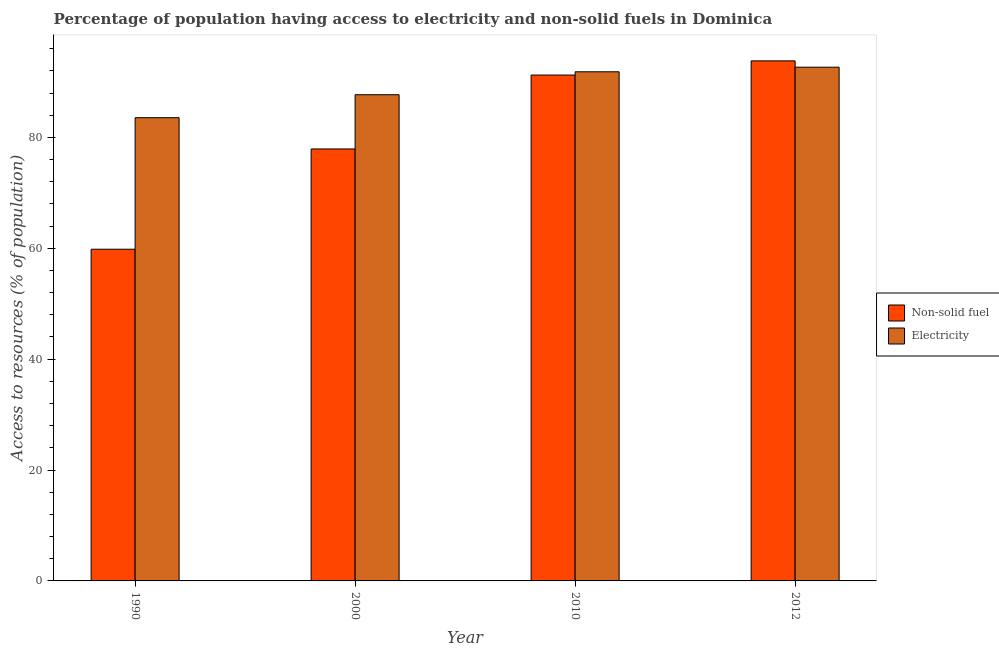Are the number of bars per tick equal to the number of legend labels?
Your answer should be compact. Yes. Are the number of bars on each tick of the X-axis equal?
Offer a very short reply. Yes. How many bars are there on the 2nd tick from the left?
Make the answer very short. 2. How many bars are there on the 2nd tick from the right?
Your answer should be compact. 2. What is the percentage of population having access to non-solid fuel in 1990?
Keep it short and to the point. 59.83. Across all years, what is the maximum percentage of population having access to electricity?
Provide a succinct answer. 92.67. Across all years, what is the minimum percentage of population having access to non-solid fuel?
Offer a terse response. 59.83. What is the total percentage of population having access to non-solid fuel in the graph?
Provide a short and direct response. 322.81. What is the difference between the percentage of population having access to non-solid fuel in 2000 and that in 2010?
Make the answer very short. -13.33. What is the difference between the percentage of population having access to non-solid fuel in 1990 and the percentage of population having access to electricity in 2012?
Provide a short and direct response. -33.97. What is the average percentage of population having access to non-solid fuel per year?
Make the answer very short. 80.7. In how many years, is the percentage of population having access to electricity greater than 48 %?
Make the answer very short. 4. What is the ratio of the percentage of population having access to non-solid fuel in 1990 to that in 2000?
Offer a very short reply. 0.77. What is the difference between the highest and the second highest percentage of population having access to non-solid fuel?
Provide a succinct answer. 2.56. What is the difference between the highest and the lowest percentage of population having access to electricity?
Your answer should be very brief. 9.11. What does the 2nd bar from the left in 2012 represents?
Offer a very short reply. Electricity. What does the 2nd bar from the right in 1990 represents?
Provide a succinct answer. Non-solid fuel. Are all the bars in the graph horizontal?
Ensure brevity in your answer.  No. How many years are there in the graph?
Make the answer very short. 4. Does the graph contain any zero values?
Offer a very short reply. No. Does the graph contain grids?
Give a very brief answer. No. Where does the legend appear in the graph?
Your response must be concise. Center right. How many legend labels are there?
Give a very brief answer. 2. How are the legend labels stacked?
Ensure brevity in your answer.  Vertical. What is the title of the graph?
Provide a succinct answer. Percentage of population having access to electricity and non-solid fuels in Dominica. What is the label or title of the X-axis?
Your response must be concise. Year. What is the label or title of the Y-axis?
Provide a succinct answer. Access to resources (% of population). What is the Access to resources (% of population) of Non-solid fuel in 1990?
Provide a short and direct response. 59.83. What is the Access to resources (% of population) in Electricity in 1990?
Your answer should be very brief. 83.56. What is the Access to resources (% of population) in Non-solid fuel in 2000?
Give a very brief answer. 77.92. What is the Access to resources (% of population) of Electricity in 2000?
Offer a terse response. 87.7. What is the Access to resources (% of population) of Non-solid fuel in 2010?
Provide a short and direct response. 91.25. What is the Access to resources (% of population) in Electricity in 2010?
Keep it short and to the point. 91.84. What is the Access to resources (% of population) of Non-solid fuel in 2012?
Give a very brief answer. 93.81. What is the Access to resources (% of population) of Electricity in 2012?
Keep it short and to the point. 92.67. Across all years, what is the maximum Access to resources (% of population) of Non-solid fuel?
Ensure brevity in your answer.  93.81. Across all years, what is the maximum Access to resources (% of population) in Electricity?
Offer a very short reply. 92.67. Across all years, what is the minimum Access to resources (% of population) of Non-solid fuel?
Give a very brief answer. 59.83. Across all years, what is the minimum Access to resources (% of population) in Electricity?
Make the answer very short. 83.56. What is the total Access to resources (% of population) of Non-solid fuel in the graph?
Your answer should be compact. 322.81. What is the total Access to resources (% of population) of Electricity in the graph?
Offer a terse response. 355.77. What is the difference between the Access to resources (% of population) of Non-solid fuel in 1990 and that in 2000?
Make the answer very short. -18.09. What is the difference between the Access to resources (% of population) in Electricity in 1990 and that in 2000?
Ensure brevity in your answer.  -4.14. What is the difference between the Access to resources (% of population) in Non-solid fuel in 1990 and that in 2010?
Your response must be concise. -31.42. What is the difference between the Access to resources (% of population) in Electricity in 1990 and that in 2010?
Offer a very short reply. -8.28. What is the difference between the Access to resources (% of population) of Non-solid fuel in 1990 and that in 2012?
Your response must be concise. -33.97. What is the difference between the Access to resources (% of population) in Electricity in 1990 and that in 2012?
Your answer should be compact. -9.11. What is the difference between the Access to resources (% of population) in Non-solid fuel in 2000 and that in 2010?
Provide a short and direct response. -13.33. What is the difference between the Access to resources (% of population) of Electricity in 2000 and that in 2010?
Your answer should be compact. -4.14. What is the difference between the Access to resources (% of population) in Non-solid fuel in 2000 and that in 2012?
Give a very brief answer. -15.89. What is the difference between the Access to resources (% of population) in Electricity in 2000 and that in 2012?
Your answer should be very brief. -4.97. What is the difference between the Access to resources (% of population) in Non-solid fuel in 2010 and that in 2012?
Give a very brief answer. -2.56. What is the difference between the Access to resources (% of population) in Electricity in 2010 and that in 2012?
Provide a short and direct response. -0.83. What is the difference between the Access to resources (% of population) of Non-solid fuel in 1990 and the Access to resources (% of population) of Electricity in 2000?
Your answer should be compact. -27.87. What is the difference between the Access to resources (% of population) of Non-solid fuel in 1990 and the Access to resources (% of population) of Electricity in 2010?
Make the answer very short. -32.01. What is the difference between the Access to resources (% of population) of Non-solid fuel in 1990 and the Access to resources (% of population) of Electricity in 2012?
Offer a terse response. -32.83. What is the difference between the Access to resources (% of population) of Non-solid fuel in 2000 and the Access to resources (% of population) of Electricity in 2010?
Ensure brevity in your answer.  -13.92. What is the difference between the Access to resources (% of population) of Non-solid fuel in 2000 and the Access to resources (% of population) of Electricity in 2012?
Offer a very short reply. -14.75. What is the difference between the Access to resources (% of population) of Non-solid fuel in 2010 and the Access to resources (% of population) of Electricity in 2012?
Provide a succinct answer. -1.42. What is the average Access to resources (% of population) in Non-solid fuel per year?
Give a very brief answer. 80.7. What is the average Access to resources (% of population) in Electricity per year?
Offer a terse response. 88.94. In the year 1990, what is the difference between the Access to resources (% of population) in Non-solid fuel and Access to resources (% of population) in Electricity?
Make the answer very short. -23.73. In the year 2000, what is the difference between the Access to resources (% of population) in Non-solid fuel and Access to resources (% of population) in Electricity?
Your answer should be very brief. -9.78. In the year 2010, what is the difference between the Access to resources (% of population) in Non-solid fuel and Access to resources (% of population) in Electricity?
Offer a terse response. -0.59. In the year 2012, what is the difference between the Access to resources (% of population) in Non-solid fuel and Access to resources (% of population) in Electricity?
Your answer should be compact. 1.14. What is the ratio of the Access to resources (% of population) of Non-solid fuel in 1990 to that in 2000?
Your answer should be very brief. 0.77. What is the ratio of the Access to resources (% of population) in Electricity in 1990 to that in 2000?
Make the answer very short. 0.95. What is the ratio of the Access to resources (% of population) of Non-solid fuel in 1990 to that in 2010?
Provide a succinct answer. 0.66. What is the ratio of the Access to resources (% of population) of Electricity in 1990 to that in 2010?
Your response must be concise. 0.91. What is the ratio of the Access to resources (% of population) of Non-solid fuel in 1990 to that in 2012?
Keep it short and to the point. 0.64. What is the ratio of the Access to resources (% of population) in Electricity in 1990 to that in 2012?
Make the answer very short. 0.9. What is the ratio of the Access to resources (% of population) of Non-solid fuel in 2000 to that in 2010?
Give a very brief answer. 0.85. What is the ratio of the Access to resources (% of population) in Electricity in 2000 to that in 2010?
Provide a short and direct response. 0.95. What is the ratio of the Access to resources (% of population) of Non-solid fuel in 2000 to that in 2012?
Ensure brevity in your answer.  0.83. What is the ratio of the Access to resources (% of population) in Electricity in 2000 to that in 2012?
Provide a short and direct response. 0.95. What is the ratio of the Access to resources (% of population) of Non-solid fuel in 2010 to that in 2012?
Your answer should be compact. 0.97. What is the difference between the highest and the second highest Access to resources (% of population) of Non-solid fuel?
Offer a very short reply. 2.56. What is the difference between the highest and the second highest Access to resources (% of population) in Electricity?
Make the answer very short. 0.83. What is the difference between the highest and the lowest Access to resources (% of population) of Non-solid fuel?
Your answer should be very brief. 33.97. What is the difference between the highest and the lowest Access to resources (% of population) in Electricity?
Provide a short and direct response. 9.11. 